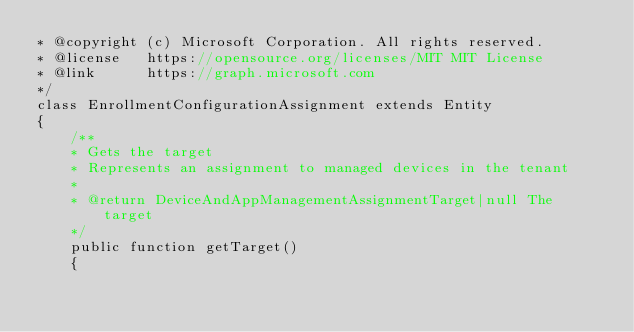Convert code to text. <code><loc_0><loc_0><loc_500><loc_500><_PHP_>* @copyright (c) Microsoft Corporation. All rights reserved.
* @license   https://opensource.org/licenses/MIT MIT License
* @link      https://graph.microsoft.com
*/
class EnrollmentConfigurationAssignment extends Entity
{
    /**
    * Gets the target
    * Represents an assignment to managed devices in the tenant
    *
    * @return DeviceAndAppManagementAssignmentTarget|null The target
    */
    public function getTarget()
    {</code> 